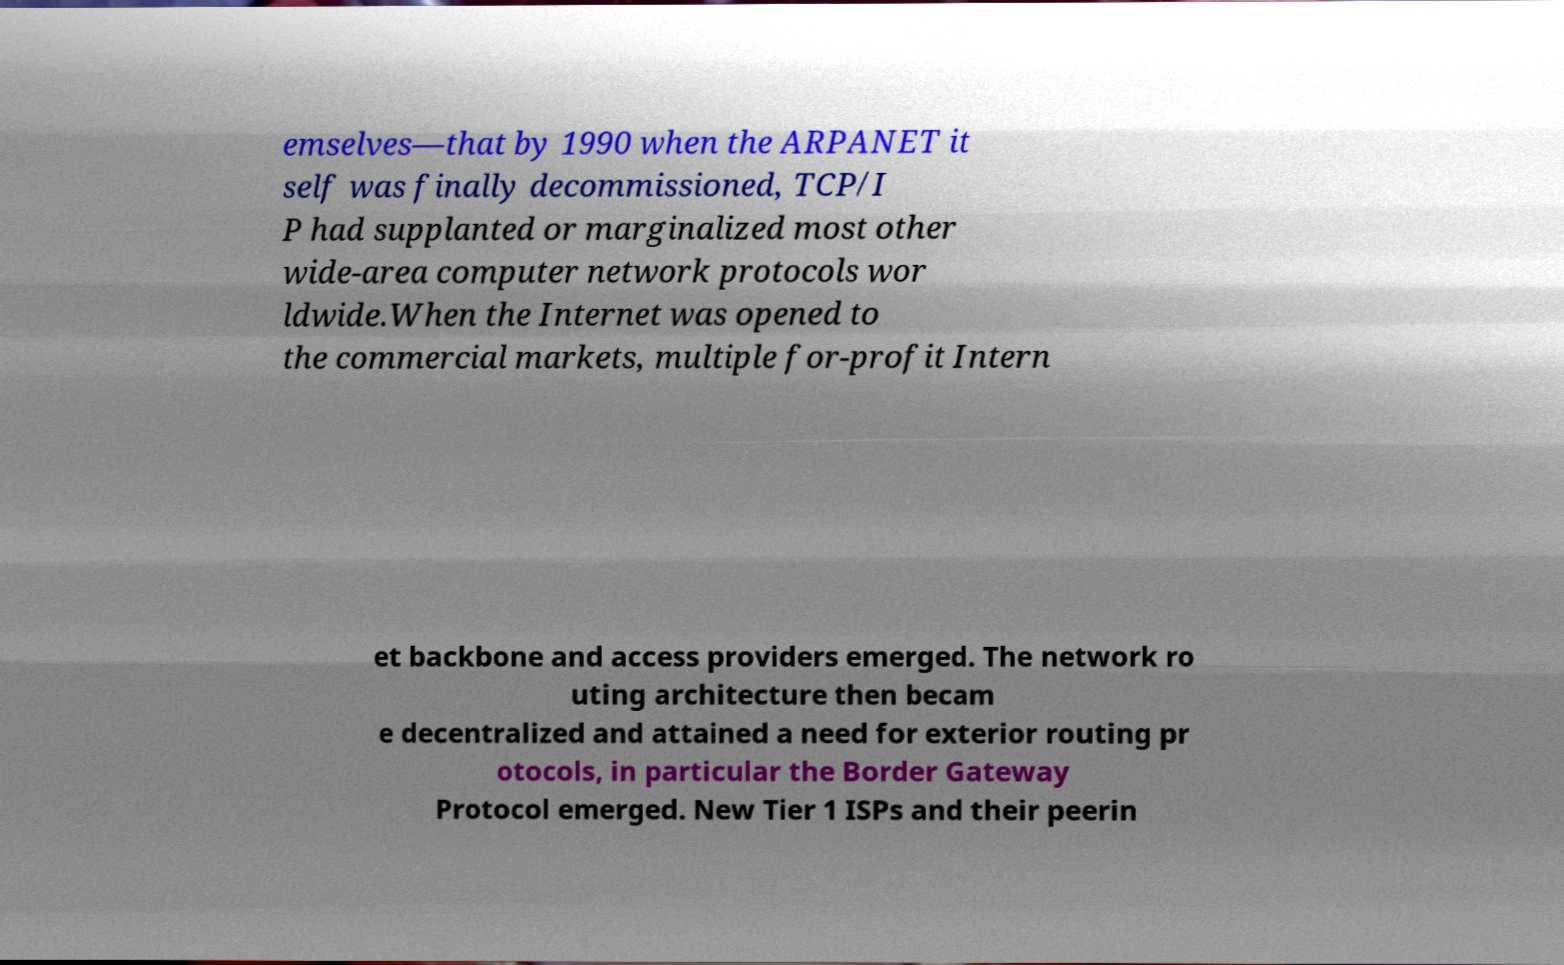Please read and relay the text visible in this image. What does it say? emselves—that by 1990 when the ARPANET it self was finally decommissioned, TCP/I P had supplanted or marginalized most other wide-area computer network protocols wor ldwide.When the Internet was opened to the commercial markets, multiple for-profit Intern et backbone and access providers emerged. The network ro uting architecture then becam e decentralized and attained a need for exterior routing pr otocols, in particular the Border Gateway Protocol emerged. New Tier 1 ISPs and their peerin 